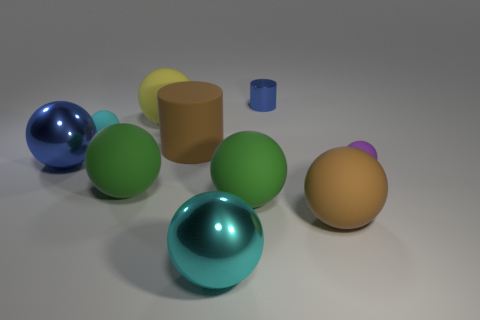Subtract all purple blocks. How many cyan balls are left? 2 Subtract all small purple matte balls. How many balls are left? 7 Subtract all cylinders. How many objects are left? 8 Subtract 2 cylinders. How many cylinders are left? 0 Add 2 brown things. How many brown things are left? 4 Add 1 large green rubber objects. How many large green rubber objects exist? 3 Subtract all blue cylinders. How many cylinders are left? 1 Subtract 0 brown cubes. How many objects are left? 10 Subtract all green balls. Subtract all gray cylinders. How many balls are left? 6 Subtract all tiny blue metallic objects. Subtract all small blue cubes. How many objects are left? 9 